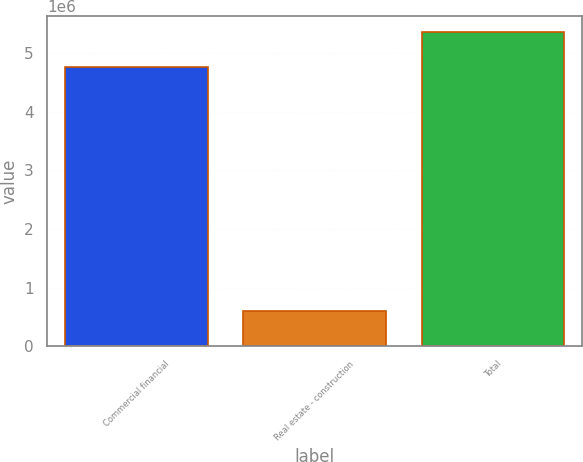Convert chart to OTSL. <chart><loc_0><loc_0><loc_500><loc_500><bar_chart><fcel>Commercial financial<fcel>Real estate - construction<fcel>Total<nl><fcel>4.76366e+06<fcel>604018<fcel>5.36767e+06<nl></chart> 